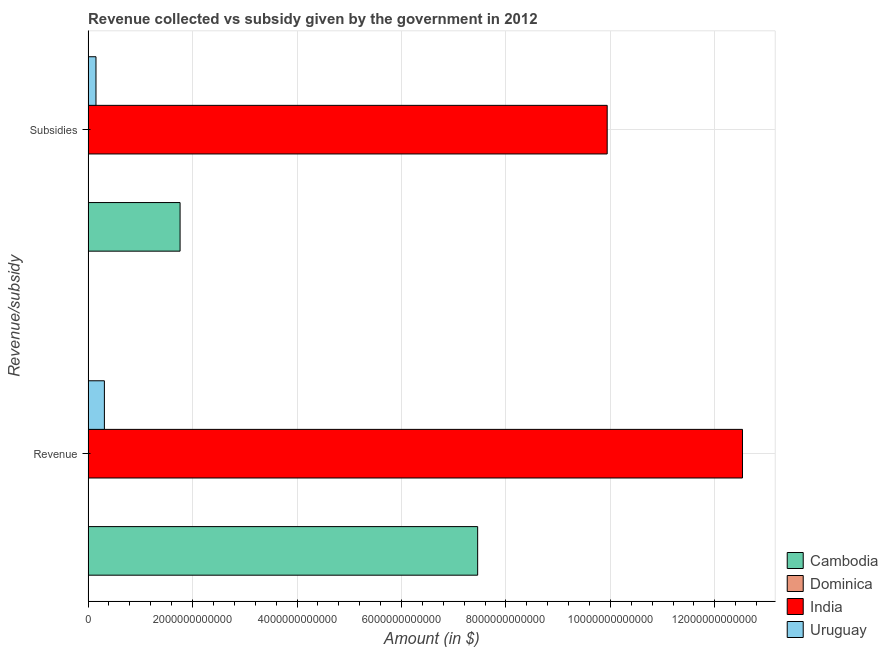How many different coloured bars are there?
Your answer should be compact. 4. How many groups of bars are there?
Your answer should be compact. 2. Are the number of bars per tick equal to the number of legend labels?
Your response must be concise. Yes. Are the number of bars on each tick of the Y-axis equal?
Make the answer very short. Yes. What is the label of the 1st group of bars from the top?
Ensure brevity in your answer.  Subsidies. What is the amount of subsidies given in Uruguay?
Provide a short and direct response. 1.51e+11. Across all countries, what is the maximum amount of subsidies given?
Provide a succinct answer. 9.94e+12. Across all countries, what is the minimum amount of subsidies given?
Make the answer very short. 6.81e+07. In which country was the amount of subsidies given minimum?
Provide a succinct answer. Dominica. What is the total amount of revenue collected in the graph?
Your answer should be compact. 2.03e+13. What is the difference between the amount of revenue collected in Uruguay and that in Cambodia?
Give a very brief answer. -7.15e+12. What is the difference between the amount of subsidies given in Uruguay and the amount of revenue collected in Cambodia?
Keep it short and to the point. -7.31e+12. What is the average amount of revenue collected per country?
Offer a terse response. 5.08e+12. What is the difference between the amount of subsidies given and amount of revenue collected in Cambodia?
Provide a succinct answer. -5.70e+12. In how many countries, is the amount of subsidies given greater than 11200000000000 $?
Give a very brief answer. 0. What is the ratio of the amount of subsidies given in Cambodia to that in India?
Your answer should be compact. 0.18. Is the amount of subsidies given in Uruguay less than that in Cambodia?
Ensure brevity in your answer.  Yes. In how many countries, is the amount of subsidies given greater than the average amount of subsidies given taken over all countries?
Your answer should be very brief. 1. What does the 1st bar from the top in Revenue represents?
Provide a short and direct response. Uruguay. What does the 3rd bar from the bottom in Revenue represents?
Offer a very short reply. India. How many bars are there?
Your answer should be compact. 8. Are all the bars in the graph horizontal?
Make the answer very short. Yes. What is the difference between two consecutive major ticks on the X-axis?
Offer a terse response. 2.00e+12. Are the values on the major ticks of X-axis written in scientific E-notation?
Your answer should be compact. No. Does the graph contain any zero values?
Provide a succinct answer. No. Where does the legend appear in the graph?
Provide a succinct answer. Bottom right. How many legend labels are there?
Your answer should be compact. 4. What is the title of the graph?
Offer a very short reply. Revenue collected vs subsidy given by the government in 2012. What is the label or title of the X-axis?
Make the answer very short. Amount (in $). What is the label or title of the Y-axis?
Provide a short and direct response. Revenue/subsidy. What is the Amount (in $) in Cambodia in Revenue?
Your answer should be compact. 7.46e+12. What is the Amount (in $) in Dominica in Revenue?
Make the answer very short. 3.49e+08. What is the Amount (in $) of India in Revenue?
Give a very brief answer. 1.25e+13. What is the Amount (in $) of Uruguay in Revenue?
Your answer should be very brief. 3.12e+11. What is the Amount (in $) in Cambodia in Subsidies?
Your answer should be very brief. 1.76e+12. What is the Amount (in $) of Dominica in Subsidies?
Ensure brevity in your answer.  6.81e+07. What is the Amount (in $) in India in Subsidies?
Provide a succinct answer. 9.94e+12. What is the Amount (in $) in Uruguay in Subsidies?
Your answer should be compact. 1.51e+11. Across all Revenue/subsidy, what is the maximum Amount (in $) in Cambodia?
Offer a very short reply. 7.46e+12. Across all Revenue/subsidy, what is the maximum Amount (in $) of Dominica?
Your answer should be very brief. 3.49e+08. Across all Revenue/subsidy, what is the maximum Amount (in $) of India?
Ensure brevity in your answer.  1.25e+13. Across all Revenue/subsidy, what is the maximum Amount (in $) in Uruguay?
Provide a short and direct response. 3.12e+11. Across all Revenue/subsidy, what is the minimum Amount (in $) in Cambodia?
Provide a succinct answer. 1.76e+12. Across all Revenue/subsidy, what is the minimum Amount (in $) of Dominica?
Make the answer very short. 6.81e+07. Across all Revenue/subsidy, what is the minimum Amount (in $) in India?
Your answer should be very brief. 9.94e+12. Across all Revenue/subsidy, what is the minimum Amount (in $) of Uruguay?
Keep it short and to the point. 1.51e+11. What is the total Amount (in $) in Cambodia in the graph?
Provide a succinct answer. 9.22e+12. What is the total Amount (in $) of Dominica in the graph?
Ensure brevity in your answer.  4.17e+08. What is the total Amount (in $) of India in the graph?
Your response must be concise. 2.25e+13. What is the total Amount (in $) of Uruguay in the graph?
Keep it short and to the point. 4.63e+11. What is the difference between the Amount (in $) in Cambodia in Revenue and that in Subsidies?
Offer a terse response. 5.70e+12. What is the difference between the Amount (in $) in Dominica in Revenue and that in Subsidies?
Keep it short and to the point. 2.81e+08. What is the difference between the Amount (in $) in India in Revenue and that in Subsidies?
Your answer should be compact. 2.59e+12. What is the difference between the Amount (in $) of Uruguay in Revenue and that in Subsidies?
Give a very brief answer. 1.61e+11. What is the difference between the Amount (in $) in Cambodia in Revenue and the Amount (in $) in Dominica in Subsidies?
Offer a terse response. 7.46e+12. What is the difference between the Amount (in $) of Cambodia in Revenue and the Amount (in $) of India in Subsidies?
Offer a terse response. -2.48e+12. What is the difference between the Amount (in $) of Cambodia in Revenue and the Amount (in $) of Uruguay in Subsidies?
Ensure brevity in your answer.  7.31e+12. What is the difference between the Amount (in $) of Dominica in Revenue and the Amount (in $) of India in Subsidies?
Offer a very short reply. -9.94e+12. What is the difference between the Amount (in $) in Dominica in Revenue and the Amount (in $) in Uruguay in Subsidies?
Provide a short and direct response. -1.51e+11. What is the difference between the Amount (in $) of India in Revenue and the Amount (in $) of Uruguay in Subsidies?
Offer a terse response. 1.24e+13. What is the average Amount (in $) of Cambodia per Revenue/subsidy?
Make the answer very short. 4.61e+12. What is the average Amount (in $) of Dominica per Revenue/subsidy?
Provide a succinct answer. 2.09e+08. What is the average Amount (in $) in India per Revenue/subsidy?
Provide a short and direct response. 1.12e+13. What is the average Amount (in $) of Uruguay per Revenue/subsidy?
Offer a terse response. 2.32e+11. What is the difference between the Amount (in $) of Cambodia and Amount (in $) of Dominica in Revenue?
Keep it short and to the point. 7.46e+12. What is the difference between the Amount (in $) in Cambodia and Amount (in $) in India in Revenue?
Ensure brevity in your answer.  -5.07e+12. What is the difference between the Amount (in $) in Cambodia and Amount (in $) in Uruguay in Revenue?
Your response must be concise. 7.15e+12. What is the difference between the Amount (in $) in Dominica and Amount (in $) in India in Revenue?
Give a very brief answer. -1.25e+13. What is the difference between the Amount (in $) of Dominica and Amount (in $) of Uruguay in Revenue?
Offer a terse response. -3.12e+11. What is the difference between the Amount (in $) in India and Amount (in $) in Uruguay in Revenue?
Offer a very short reply. 1.22e+13. What is the difference between the Amount (in $) of Cambodia and Amount (in $) of Dominica in Subsidies?
Your answer should be very brief. 1.76e+12. What is the difference between the Amount (in $) in Cambodia and Amount (in $) in India in Subsidies?
Keep it short and to the point. -8.18e+12. What is the difference between the Amount (in $) of Cambodia and Amount (in $) of Uruguay in Subsidies?
Provide a succinct answer. 1.61e+12. What is the difference between the Amount (in $) in Dominica and Amount (in $) in India in Subsidies?
Provide a succinct answer. -9.94e+12. What is the difference between the Amount (in $) of Dominica and Amount (in $) of Uruguay in Subsidies?
Your response must be concise. -1.51e+11. What is the difference between the Amount (in $) in India and Amount (in $) in Uruguay in Subsidies?
Your response must be concise. 9.79e+12. What is the ratio of the Amount (in $) in Cambodia in Revenue to that in Subsidies?
Offer a very short reply. 4.23. What is the ratio of the Amount (in $) in Dominica in Revenue to that in Subsidies?
Give a very brief answer. 5.13. What is the ratio of the Amount (in $) in India in Revenue to that in Subsidies?
Provide a succinct answer. 1.26. What is the ratio of the Amount (in $) in Uruguay in Revenue to that in Subsidies?
Your response must be concise. 2.06. What is the difference between the highest and the second highest Amount (in $) of Cambodia?
Offer a very short reply. 5.70e+12. What is the difference between the highest and the second highest Amount (in $) of Dominica?
Your response must be concise. 2.81e+08. What is the difference between the highest and the second highest Amount (in $) of India?
Provide a short and direct response. 2.59e+12. What is the difference between the highest and the second highest Amount (in $) in Uruguay?
Make the answer very short. 1.61e+11. What is the difference between the highest and the lowest Amount (in $) in Cambodia?
Your answer should be very brief. 5.70e+12. What is the difference between the highest and the lowest Amount (in $) in Dominica?
Offer a terse response. 2.81e+08. What is the difference between the highest and the lowest Amount (in $) in India?
Offer a very short reply. 2.59e+12. What is the difference between the highest and the lowest Amount (in $) of Uruguay?
Offer a terse response. 1.61e+11. 